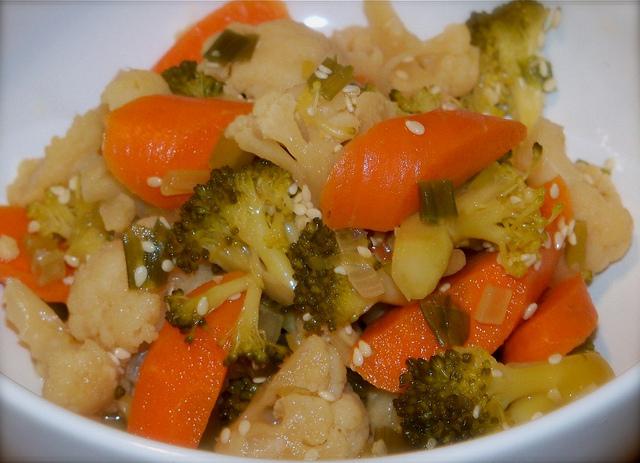Has the food been cooked or is it being served raw?
Short answer required. Cooked. How many kinds of vegetables are there?
Keep it brief. 3. What is the orange food?
Give a very brief answer. Carrots. 